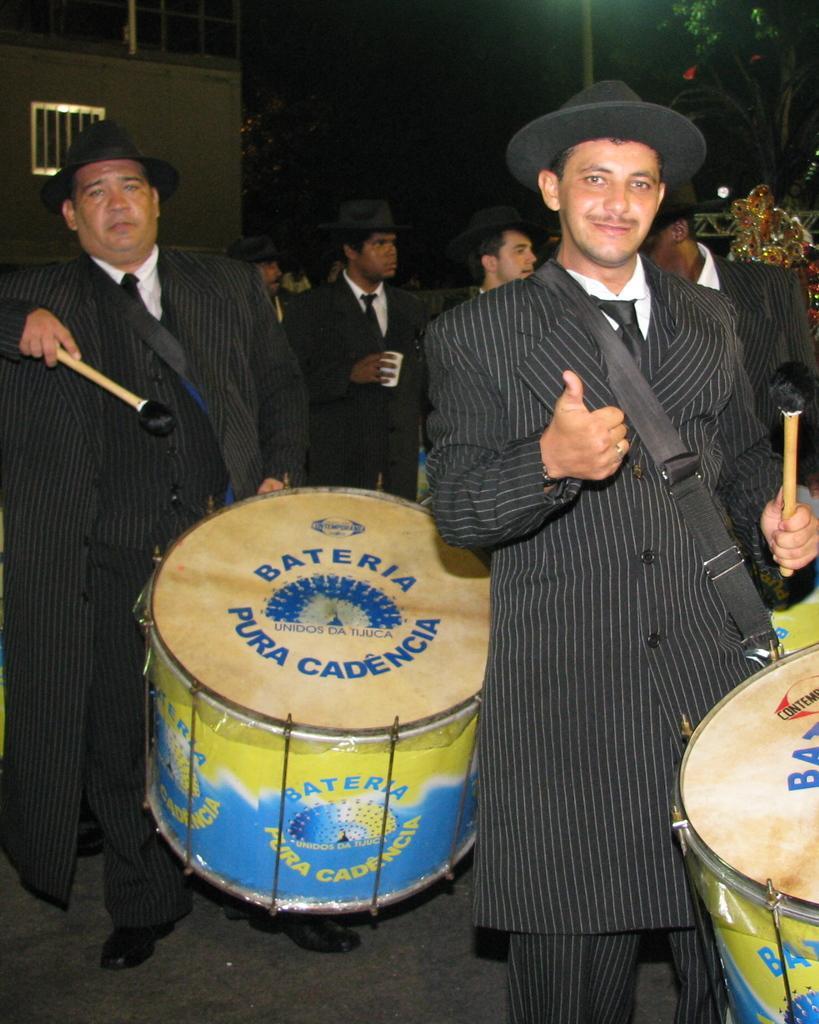In one or two sentences, can you explain what this image depicts? Two men are walking and playing drums They tied drums using black color strap. They are wearing long black coat and black hat. There are some other men with same attire. There is a house in the background. 